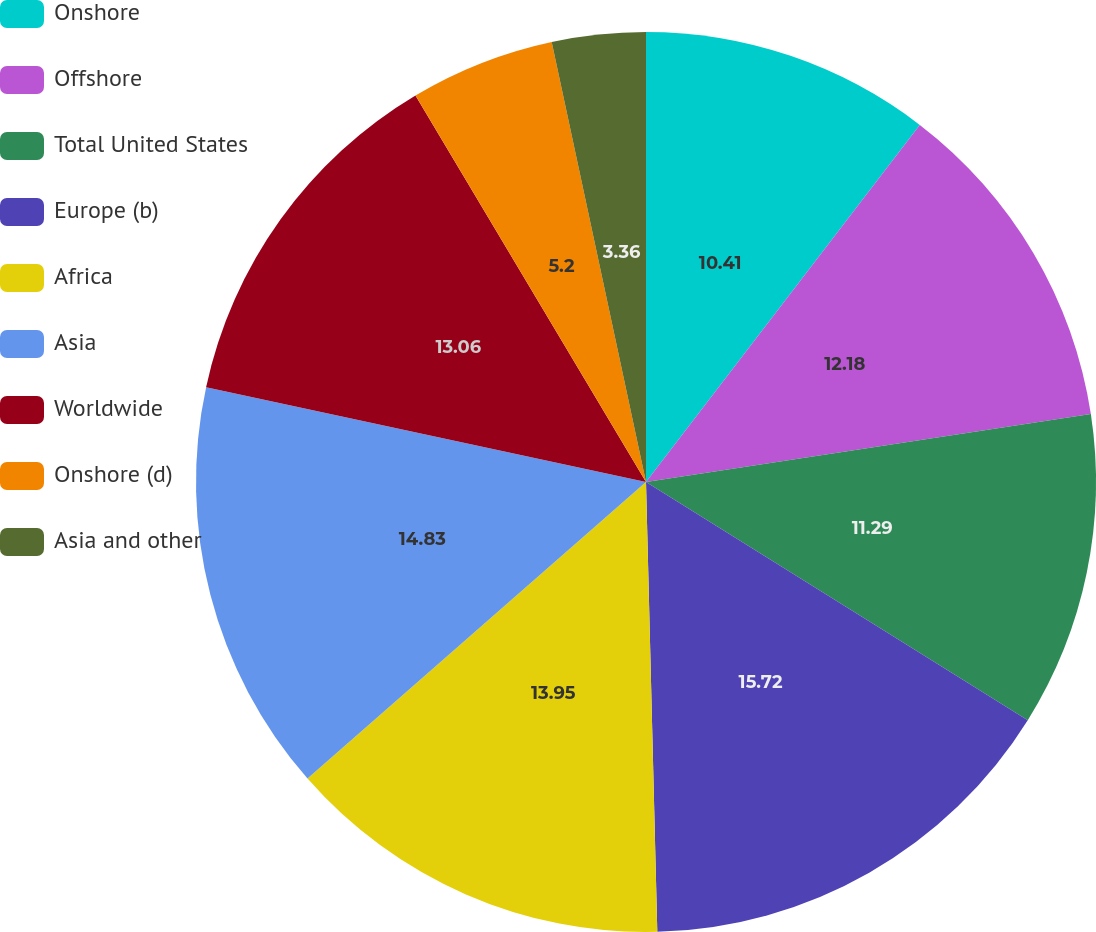Convert chart to OTSL. <chart><loc_0><loc_0><loc_500><loc_500><pie_chart><fcel>Onshore<fcel>Offshore<fcel>Total United States<fcel>Europe (b)<fcel>Africa<fcel>Asia<fcel>Worldwide<fcel>Onshore (d)<fcel>Asia and other<nl><fcel>10.41%<fcel>12.18%<fcel>11.29%<fcel>15.72%<fcel>13.95%<fcel>14.83%<fcel>13.06%<fcel>5.2%<fcel>3.36%<nl></chart> 